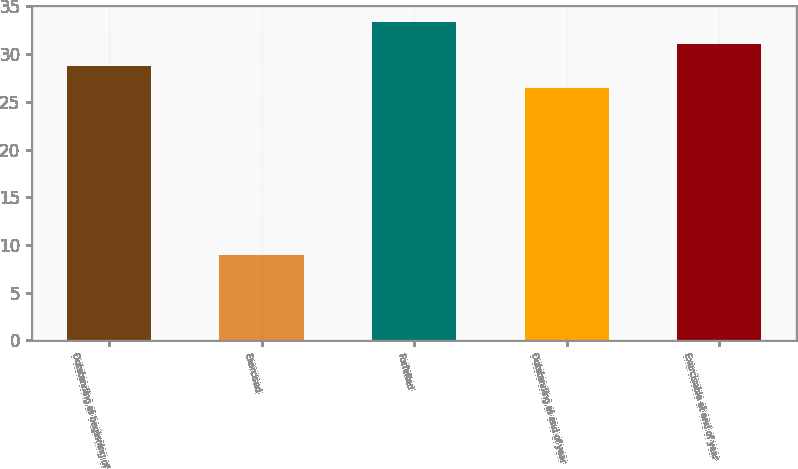<chart> <loc_0><loc_0><loc_500><loc_500><bar_chart><fcel>Outstanding at beginning of<fcel>Exercised<fcel>Forfeited<fcel>Outstanding at end of year<fcel>Exercisable at end of year<nl><fcel>28.78<fcel>8.99<fcel>33.4<fcel>26.47<fcel>31.09<nl></chart> 